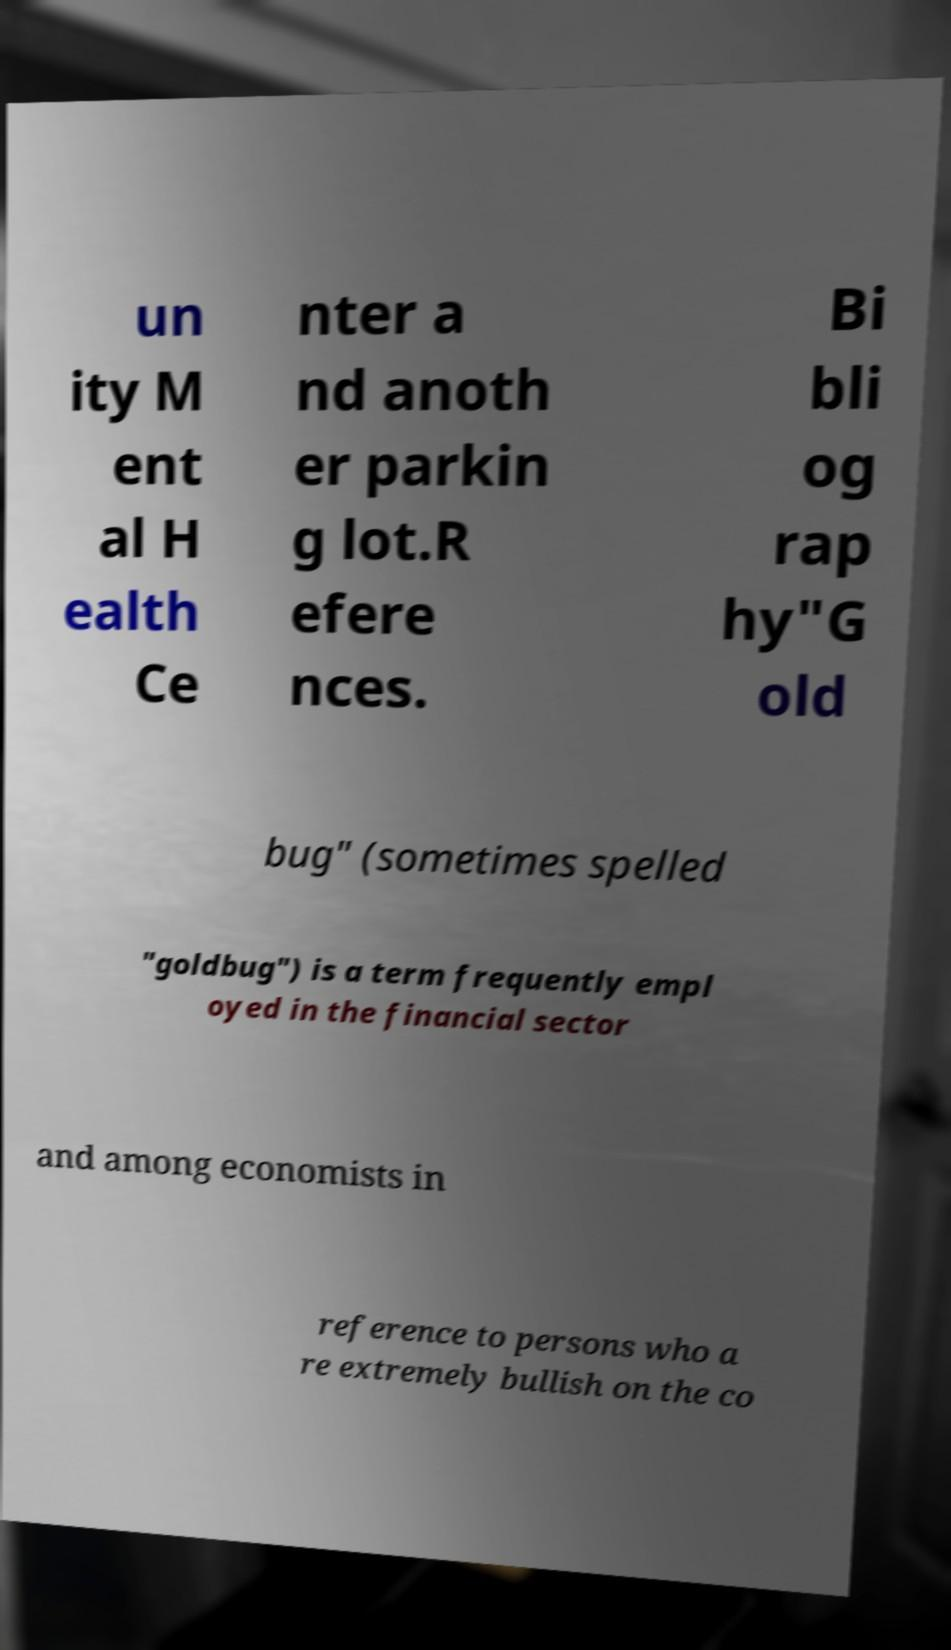What messages or text are displayed in this image? I need them in a readable, typed format. un ity M ent al H ealth Ce nter a nd anoth er parkin g lot.R efere nces. Bi bli og rap hy"G old bug" (sometimes spelled "goldbug") is a term frequently empl oyed in the financial sector and among economists in reference to persons who a re extremely bullish on the co 